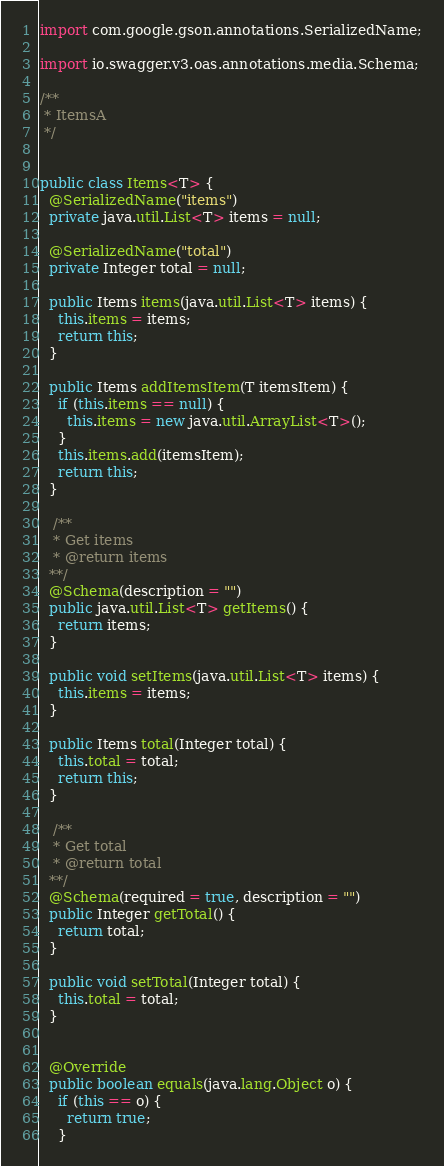<code> <loc_0><loc_0><loc_500><loc_500><_Java_>import com.google.gson.annotations.SerializedName;

import io.swagger.v3.oas.annotations.media.Schema;

/**
 * ItemsA
 */


public class Items<T> {
  @SerializedName("items")
  private java.util.List<T> items = null;

  @SerializedName("total")
  private Integer total = null;

  public Items items(java.util.List<T> items) {
    this.items = items;
    return this;
  }

  public Items addItemsItem(T itemsItem) {
    if (this.items == null) {
      this.items = new java.util.ArrayList<T>();
    }
    this.items.add(itemsItem);
    return this;
  }

   /**
   * Get items
   * @return items
  **/
  @Schema(description = "")
  public java.util.List<T> getItems() {
    return items;
  }

  public void setItems(java.util.List<T> items) {
    this.items = items;
  }

  public Items total(Integer total) {
    this.total = total;
    return this;
  }

   /**
   * Get total
   * @return total
  **/
  @Schema(required = true, description = "")
  public Integer getTotal() {
    return total;
  }

  public void setTotal(Integer total) {
    this.total = total;
  }


  @Override
  public boolean equals(java.lang.Object o) {
    if (this == o) {
      return true;
    }</code> 